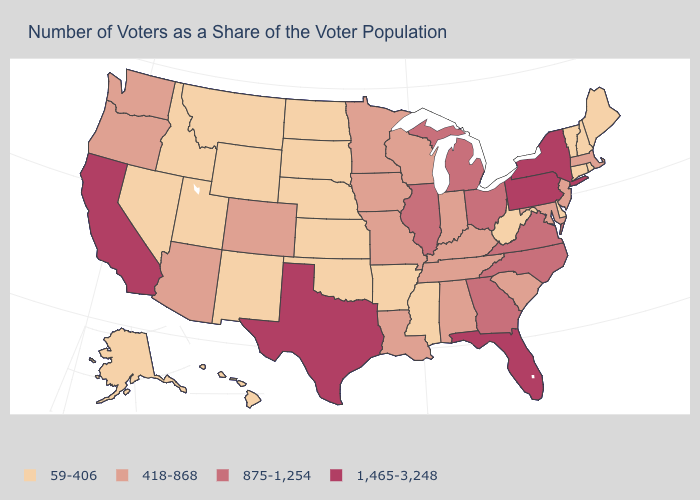Is the legend a continuous bar?
Quick response, please. No. Name the states that have a value in the range 59-406?
Answer briefly. Alaska, Arkansas, Connecticut, Delaware, Hawaii, Idaho, Kansas, Maine, Mississippi, Montana, Nebraska, Nevada, New Hampshire, New Mexico, North Dakota, Oklahoma, Rhode Island, South Dakota, Utah, Vermont, West Virginia, Wyoming. What is the value of Mississippi?
Keep it brief. 59-406. Is the legend a continuous bar?
Keep it brief. No. Which states have the lowest value in the South?
Answer briefly. Arkansas, Delaware, Mississippi, Oklahoma, West Virginia. Name the states that have a value in the range 1,465-3,248?
Short answer required. California, Florida, New York, Pennsylvania, Texas. What is the highest value in states that border Washington?
Short answer required. 418-868. What is the highest value in states that border Utah?
Quick response, please. 418-868. What is the value of Oregon?
Short answer required. 418-868. Name the states that have a value in the range 1,465-3,248?
Keep it brief. California, Florida, New York, Pennsylvania, Texas. Does Wisconsin have the highest value in the MidWest?
Write a very short answer. No. How many symbols are there in the legend?
Give a very brief answer. 4. Name the states that have a value in the range 418-868?
Write a very short answer. Alabama, Arizona, Colorado, Indiana, Iowa, Kentucky, Louisiana, Maryland, Massachusetts, Minnesota, Missouri, New Jersey, Oregon, South Carolina, Tennessee, Washington, Wisconsin. Does California have the highest value in the USA?
Concise answer only. Yes. Does the map have missing data?
Be succinct. No. 